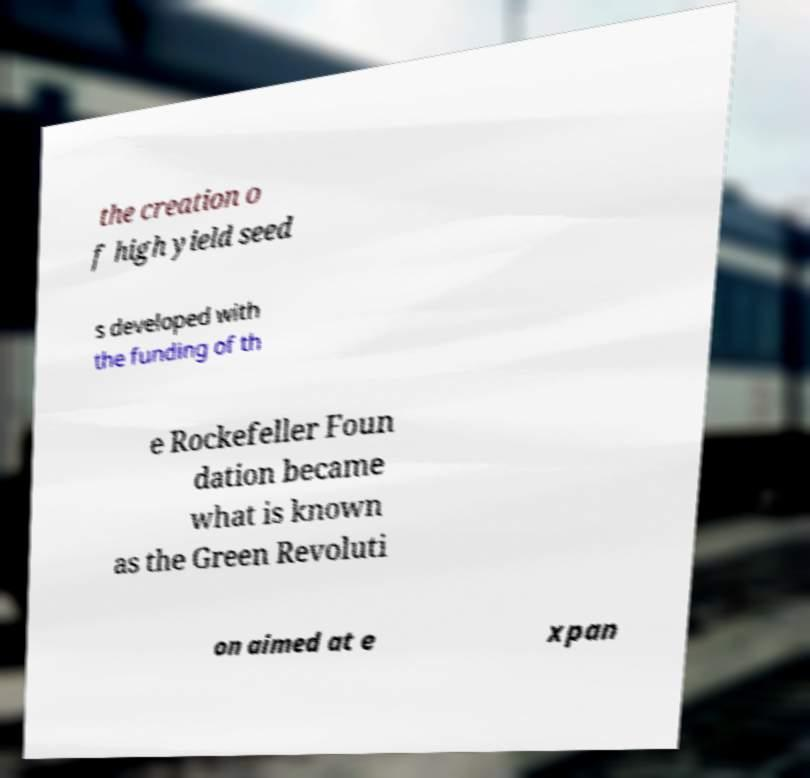Could you assist in decoding the text presented in this image and type it out clearly? the creation o f high yield seed s developed with the funding of th e Rockefeller Foun dation became what is known as the Green Revoluti on aimed at e xpan 